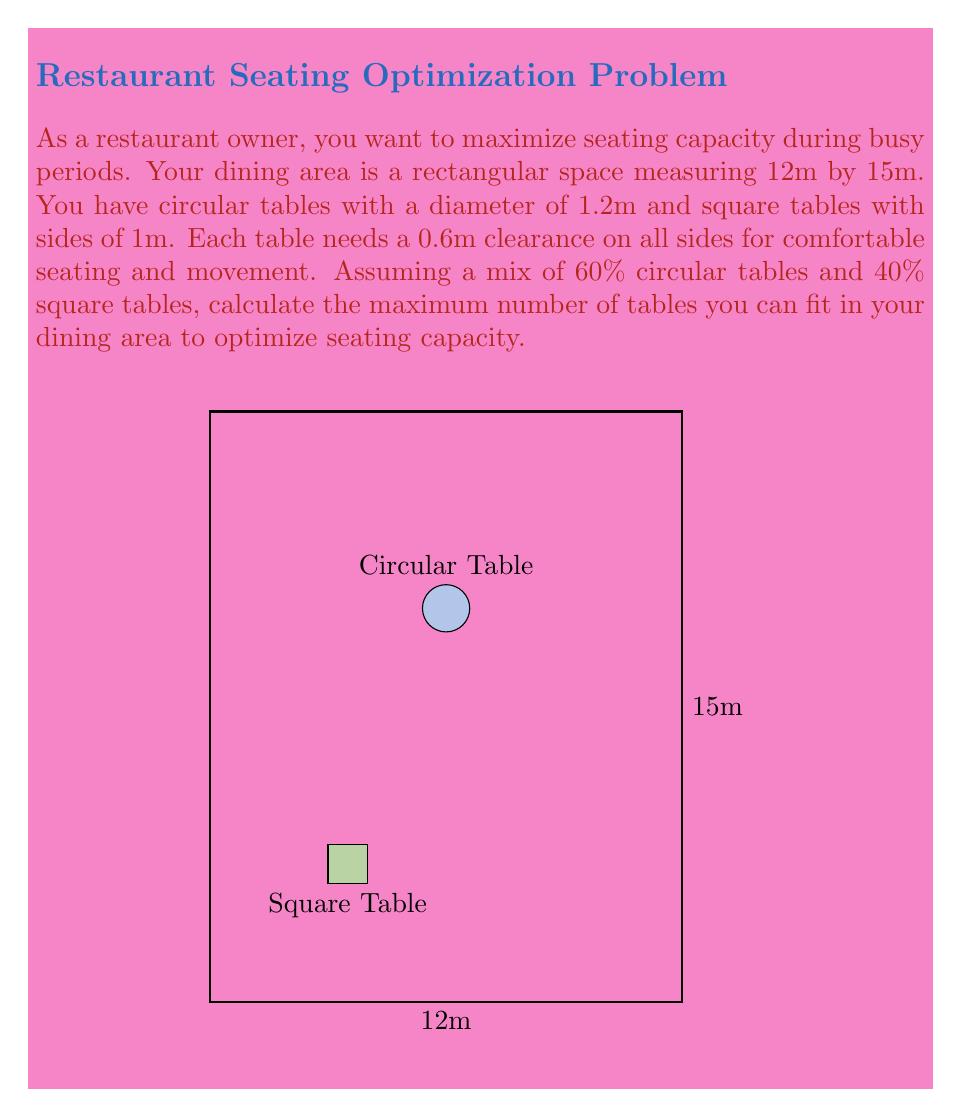Can you answer this question? Let's approach this problem step by step:

1) First, we need to calculate the effective space each table occupies, including the clearance:
   - For circular tables: Diameter + 2 * clearance = 1.2m + 2 * 0.6m = 2.4m
   - For square tables: Side + 2 * clearance = 1m + 2 * 0.6m = 2.2m

2) Now, let's calculate how many tables of each type can fit along each dimension:
   - Along 12m: 
     Circular: $\lfloor \frac{12}{2.4} \rfloor = 5$
     Square: $\lfloor \frac{12}{2.2} \rfloor = 5$
   - Along 15m:
     Circular: $\lfloor \frac{15}{2.4} \rfloor = 6$
     Square: $\lfloor \frac{15}{2.2} \rfloor = 6$

3) Total possible arrangements:
   - Circular: 5 * 6 = 30
   - Square: 5 * 6 = 30

4) Given the mix of 60% circular and 40% square tables:
   - Circular tables: $0.6 * 30 = 18$
   - Square tables: $0.4 * 30 = 12$

5) Total number of tables: 18 + 12 = 30

Therefore, the maximum number of tables that can fit in the dining area while maintaining the required mix is 30.
Answer: 30 tables 